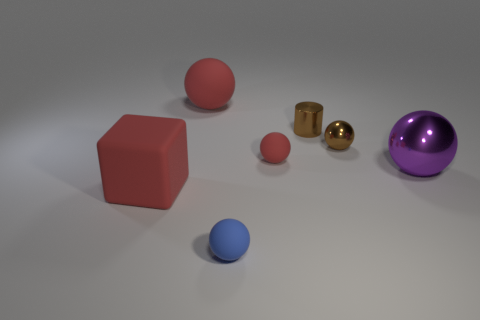If we consider these objects are part of a set, what might they represent or be used for? If these objects are part of a set, they might represent a collection for a visual demonstration of geometry and materials. The objects could be used for educational purposes to teach about shapes, volumes, and light interactions with different surfaces. 